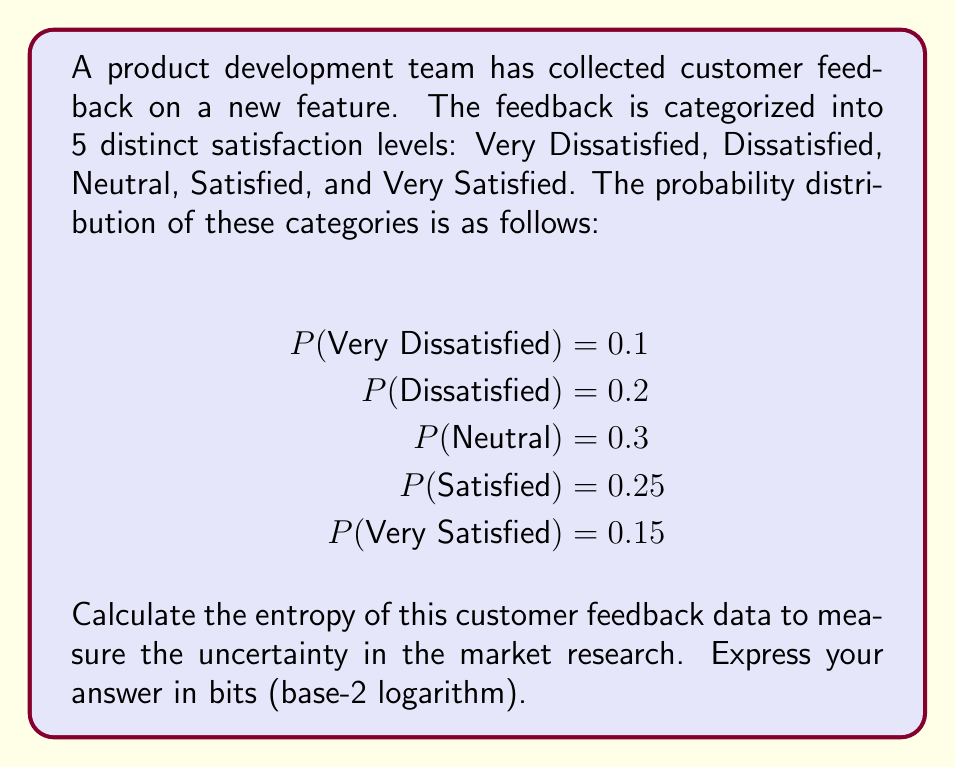Help me with this question. To calculate the entropy of the customer feedback data, we'll use the Shannon entropy formula:

$$H = -\sum_{i=1}^{n} p_i \log_2(p_i)$$

Where $p_i$ is the probability of each outcome, and $n$ is the number of possible outcomes.

Step 1: Calculate each term of the sum:
1. $-0.1 \log_2(0.1) = 0.332$
2. $-0.2 \log_2(0.2) = 0.464$
3. $-0.3 \log_2(0.3) = 0.521$
4. $-0.25 \log_2(0.25) = 0.5$
5. $-0.15 \log_2(0.15) = 0.411$

Step 2: Sum all the terms:
$$H = 0.332 + 0.464 + 0.521 + 0.5 + 0.411 = 2.228$$

The entropy of the customer feedback data is approximately 2.228 bits.
Answer: 2.228 bits 